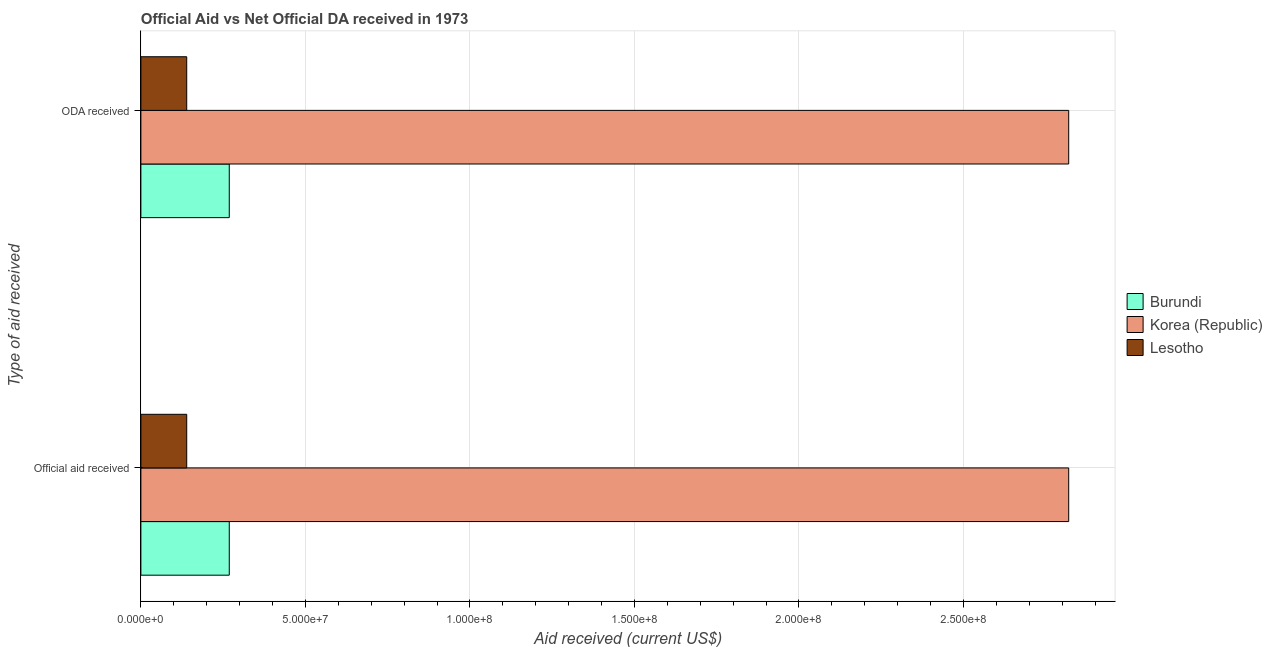What is the label of the 2nd group of bars from the top?
Provide a short and direct response. Official aid received. What is the oda received in Korea (Republic)?
Offer a very short reply. 2.82e+08. Across all countries, what is the maximum official aid received?
Provide a short and direct response. 2.82e+08. Across all countries, what is the minimum oda received?
Provide a short and direct response. 1.39e+07. In which country was the oda received maximum?
Offer a very short reply. Korea (Republic). In which country was the oda received minimum?
Make the answer very short. Lesotho. What is the total oda received in the graph?
Ensure brevity in your answer.  3.23e+08. What is the difference between the oda received in Korea (Republic) and that in Burundi?
Provide a short and direct response. 2.55e+08. What is the difference between the official aid received in Korea (Republic) and the oda received in Burundi?
Give a very brief answer. 2.55e+08. What is the average oda received per country?
Your answer should be compact. 1.08e+08. What is the ratio of the official aid received in Burundi to that in Korea (Republic)?
Offer a terse response. 0.1. In how many countries, is the official aid received greater than the average official aid received taken over all countries?
Ensure brevity in your answer.  1. What does the 3rd bar from the top in ODA received represents?
Provide a short and direct response. Burundi. How many bars are there?
Your answer should be compact. 6. Are all the bars in the graph horizontal?
Your answer should be very brief. Yes. Are the values on the major ticks of X-axis written in scientific E-notation?
Your answer should be very brief. Yes. How are the legend labels stacked?
Your answer should be compact. Vertical. What is the title of the graph?
Ensure brevity in your answer.  Official Aid vs Net Official DA received in 1973 . What is the label or title of the X-axis?
Make the answer very short. Aid received (current US$). What is the label or title of the Y-axis?
Give a very brief answer. Type of aid received. What is the Aid received (current US$) in Burundi in Official aid received?
Your answer should be very brief. 2.69e+07. What is the Aid received (current US$) of Korea (Republic) in Official aid received?
Offer a very short reply. 2.82e+08. What is the Aid received (current US$) of Lesotho in Official aid received?
Make the answer very short. 1.39e+07. What is the Aid received (current US$) of Burundi in ODA received?
Your response must be concise. 2.69e+07. What is the Aid received (current US$) in Korea (Republic) in ODA received?
Keep it short and to the point. 2.82e+08. What is the Aid received (current US$) of Lesotho in ODA received?
Your answer should be very brief. 1.39e+07. Across all Type of aid received, what is the maximum Aid received (current US$) in Burundi?
Provide a short and direct response. 2.69e+07. Across all Type of aid received, what is the maximum Aid received (current US$) of Korea (Republic)?
Keep it short and to the point. 2.82e+08. Across all Type of aid received, what is the maximum Aid received (current US$) in Lesotho?
Make the answer very short. 1.39e+07. Across all Type of aid received, what is the minimum Aid received (current US$) of Burundi?
Offer a very short reply. 2.69e+07. Across all Type of aid received, what is the minimum Aid received (current US$) in Korea (Republic)?
Your answer should be compact. 2.82e+08. Across all Type of aid received, what is the minimum Aid received (current US$) in Lesotho?
Give a very brief answer. 1.39e+07. What is the total Aid received (current US$) of Burundi in the graph?
Provide a succinct answer. 5.37e+07. What is the total Aid received (current US$) in Korea (Republic) in the graph?
Offer a terse response. 5.64e+08. What is the total Aid received (current US$) of Lesotho in the graph?
Offer a terse response. 2.79e+07. What is the difference between the Aid received (current US$) of Burundi in Official aid received and the Aid received (current US$) of Korea (Republic) in ODA received?
Provide a short and direct response. -2.55e+08. What is the difference between the Aid received (current US$) of Burundi in Official aid received and the Aid received (current US$) of Lesotho in ODA received?
Your answer should be compact. 1.29e+07. What is the difference between the Aid received (current US$) of Korea (Republic) in Official aid received and the Aid received (current US$) of Lesotho in ODA received?
Your answer should be very brief. 2.68e+08. What is the average Aid received (current US$) of Burundi per Type of aid received?
Your answer should be compact. 2.69e+07. What is the average Aid received (current US$) in Korea (Republic) per Type of aid received?
Give a very brief answer. 2.82e+08. What is the average Aid received (current US$) of Lesotho per Type of aid received?
Ensure brevity in your answer.  1.39e+07. What is the difference between the Aid received (current US$) of Burundi and Aid received (current US$) of Korea (Republic) in Official aid received?
Give a very brief answer. -2.55e+08. What is the difference between the Aid received (current US$) in Burundi and Aid received (current US$) in Lesotho in Official aid received?
Provide a short and direct response. 1.29e+07. What is the difference between the Aid received (current US$) of Korea (Republic) and Aid received (current US$) of Lesotho in Official aid received?
Offer a very short reply. 2.68e+08. What is the difference between the Aid received (current US$) of Burundi and Aid received (current US$) of Korea (Republic) in ODA received?
Your answer should be very brief. -2.55e+08. What is the difference between the Aid received (current US$) of Burundi and Aid received (current US$) of Lesotho in ODA received?
Keep it short and to the point. 1.29e+07. What is the difference between the Aid received (current US$) of Korea (Republic) and Aid received (current US$) of Lesotho in ODA received?
Offer a terse response. 2.68e+08. What is the ratio of the Aid received (current US$) in Burundi in Official aid received to that in ODA received?
Offer a very short reply. 1. What is the ratio of the Aid received (current US$) in Korea (Republic) in Official aid received to that in ODA received?
Your answer should be very brief. 1. What is the difference between the highest and the lowest Aid received (current US$) of Korea (Republic)?
Offer a terse response. 0. What is the difference between the highest and the lowest Aid received (current US$) of Lesotho?
Your answer should be compact. 0. 